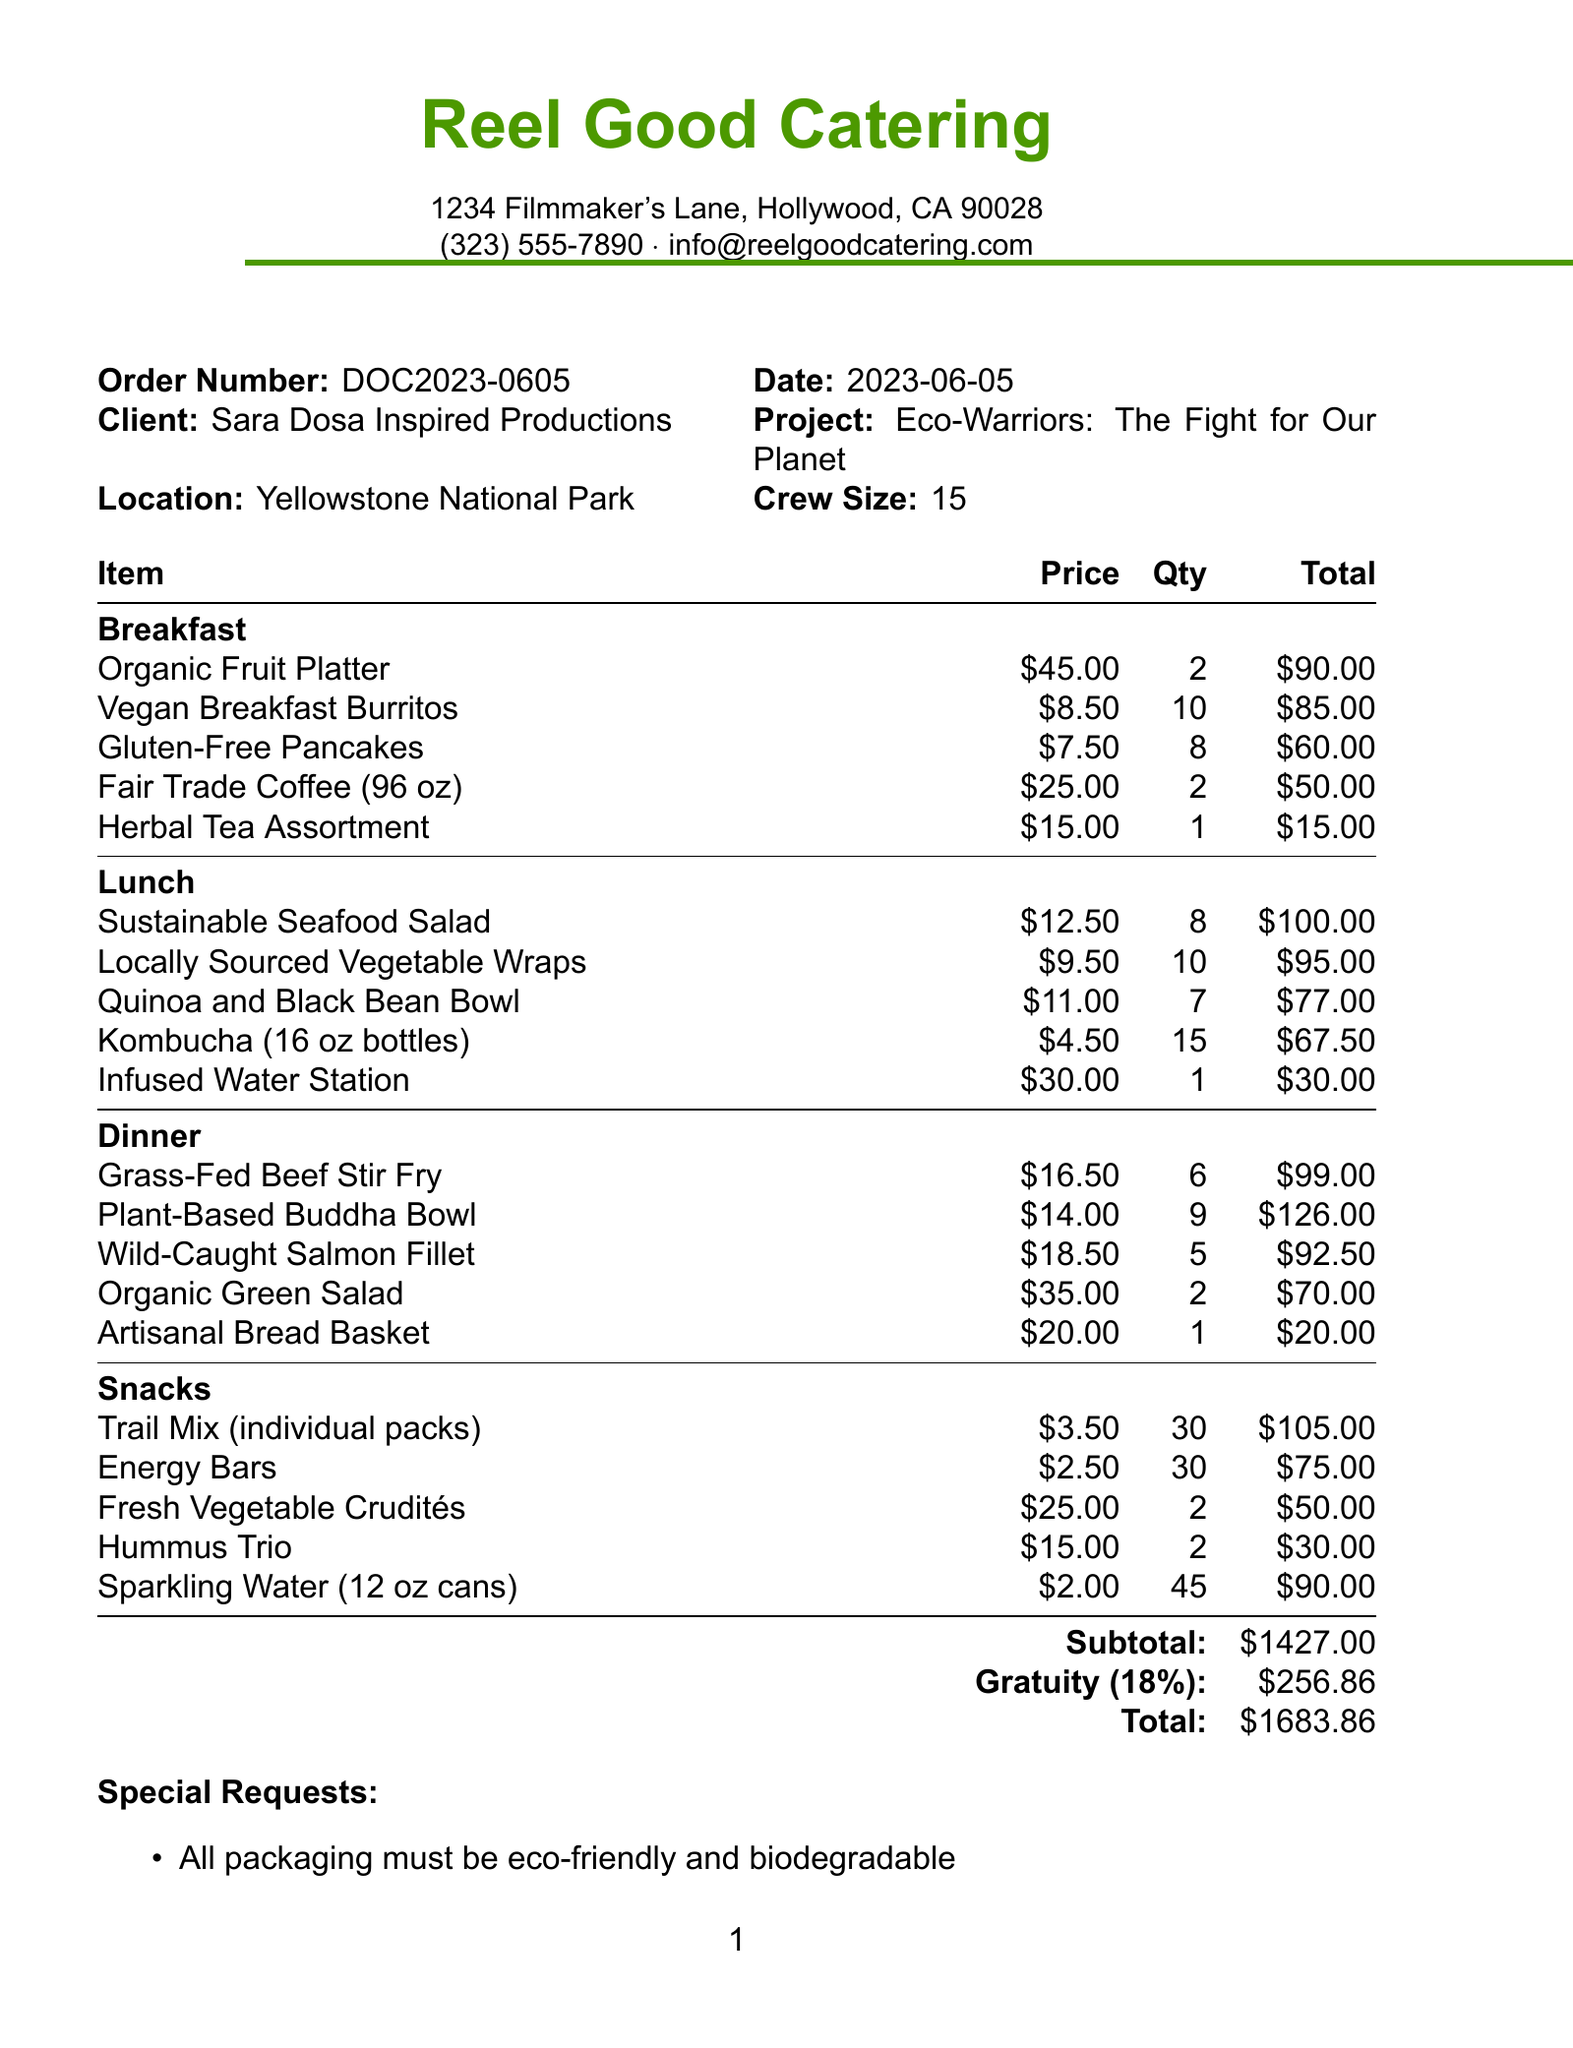What is the total amount of the order? The total amount is the final sum of the meal options, including gratuity, which is $1427.00 + $256.86.
Answer: $1683.86 Who is the client for this catering order? The client is stated as Sara Dosa Inspired Productions in the document.
Answer: Sara Dosa Inspired Productions What is the project title associated with this order? The project title is mentioned and is essential to identifying the context of the catering request.
Answer: Eco-Warriors: The Fight for Our Planet How many crew members are being catered for? The crew size is explicitly noted in the document and reflects the scale of the catering order.
Answer: 15 What item in the breakfast category is priced at $25.00? This requires identifying specific items under the breakfast section with the given price.
Answer: Fair Trade Coffee (96 oz) What percentage is the gratuity based on the subtotal? The gratuity percentage is mentioned directly in the document below the subtotal information.
Answer: 18% What is one requirement stated in the special requests? The special requests section includes specific asks from the client related to the meal orders.
Answer: All packaging must be eco-friendly and biodegradable What sustainable practice is mentioned regarding food waste? This requires connecting the specific sustainability efforts outlined in the document.
Answer: All food waste is composted Which beverage is included in the snacks section at a price of $2.00? This specifies a particular snack item by its price, which can be found easily in the document.
Answer: Sparkling Water (12 oz cans) 